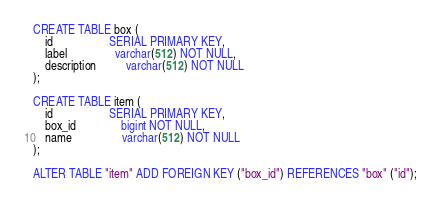<code> <loc_0><loc_0><loc_500><loc_500><_SQL_>CREATE TABLE box ( 
	id                   SERIAL PRIMARY KEY,
	label                varchar(512) NOT NULL,
	description          varchar(512) NOT NULL
);

CREATE TABLE item ( 
	id                   SERIAL PRIMARY KEY,
	box_id               bigint NOT NULL,
	name                 varchar(512) NOT NULL
);

ALTER TABLE "item" ADD FOREIGN KEY ("box_id") REFERENCES "box" ("id");</code> 